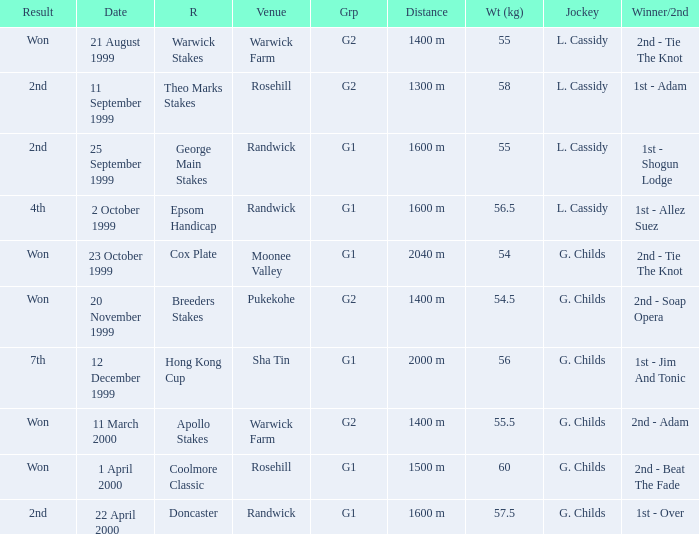Parse the table in full. {'header': ['Result', 'Date', 'R', 'Venue', 'Grp', 'Distance', 'Wt (kg)', 'Jockey', 'Winner/2nd'], 'rows': [['Won', '21 August 1999', 'Warwick Stakes', 'Warwick Farm', 'G2', '1400 m', '55', 'L. Cassidy', '2nd - Tie The Knot'], ['2nd', '11 September 1999', 'Theo Marks Stakes', 'Rosehill', 'G2', '1300 m', '58', 'L. Cassidy', '1st - Adam'], ['2nd', '25 September 1999', 'George Main Stakes', 'Randwick', 'G1', '1600 m', '55', 'L. Cassidy', '1st - Shogun Lodge'], ['4th', '2 October 1999', 'Epsom Handicap', 'Randwick', 'G1', '1600 m', '56.5', 'L. Cassidy', '1st - Allez Suez'], ['Won', '23 October 1999', 'Cox Plate', 'Moonee Valley', 'G1', '2040 m', '54', 'G. Childs', '2nd - Tie The Knot'], ['Won', '20 November 1999', 'Breeders Stakes', 'Pukekohe', 'G2', '1400 m', '54.5', 'G. Childs', '2nd - Soap Opera'], ['7th', '12 December 1999', 'Hong Kong Cup', 'Sha Tin', 'G1', '2000 m', '56', 'G. Childs', '1st - Jim And Tonic'], ['Won', '11 March 2000', 'Apollo Stakes', 'Warwick Farm', 'G2', '1400 m', '55.5', 'G. Childs', '2nd - Adam'], ['Won', '1 April 2000', 'Coolmore Classic', 'Rosehill', 'G1', '1500 m', '60', 'G. Childs', '2nd - Beat The Fade'], ['2nd', '22 April 2000', 'Doncaster', 'Randwick', 'G1', '1600 m', '57.5', 'G. Childs', '1st - Over']]} How man teams had a total weight of 57.5? 1.0. 